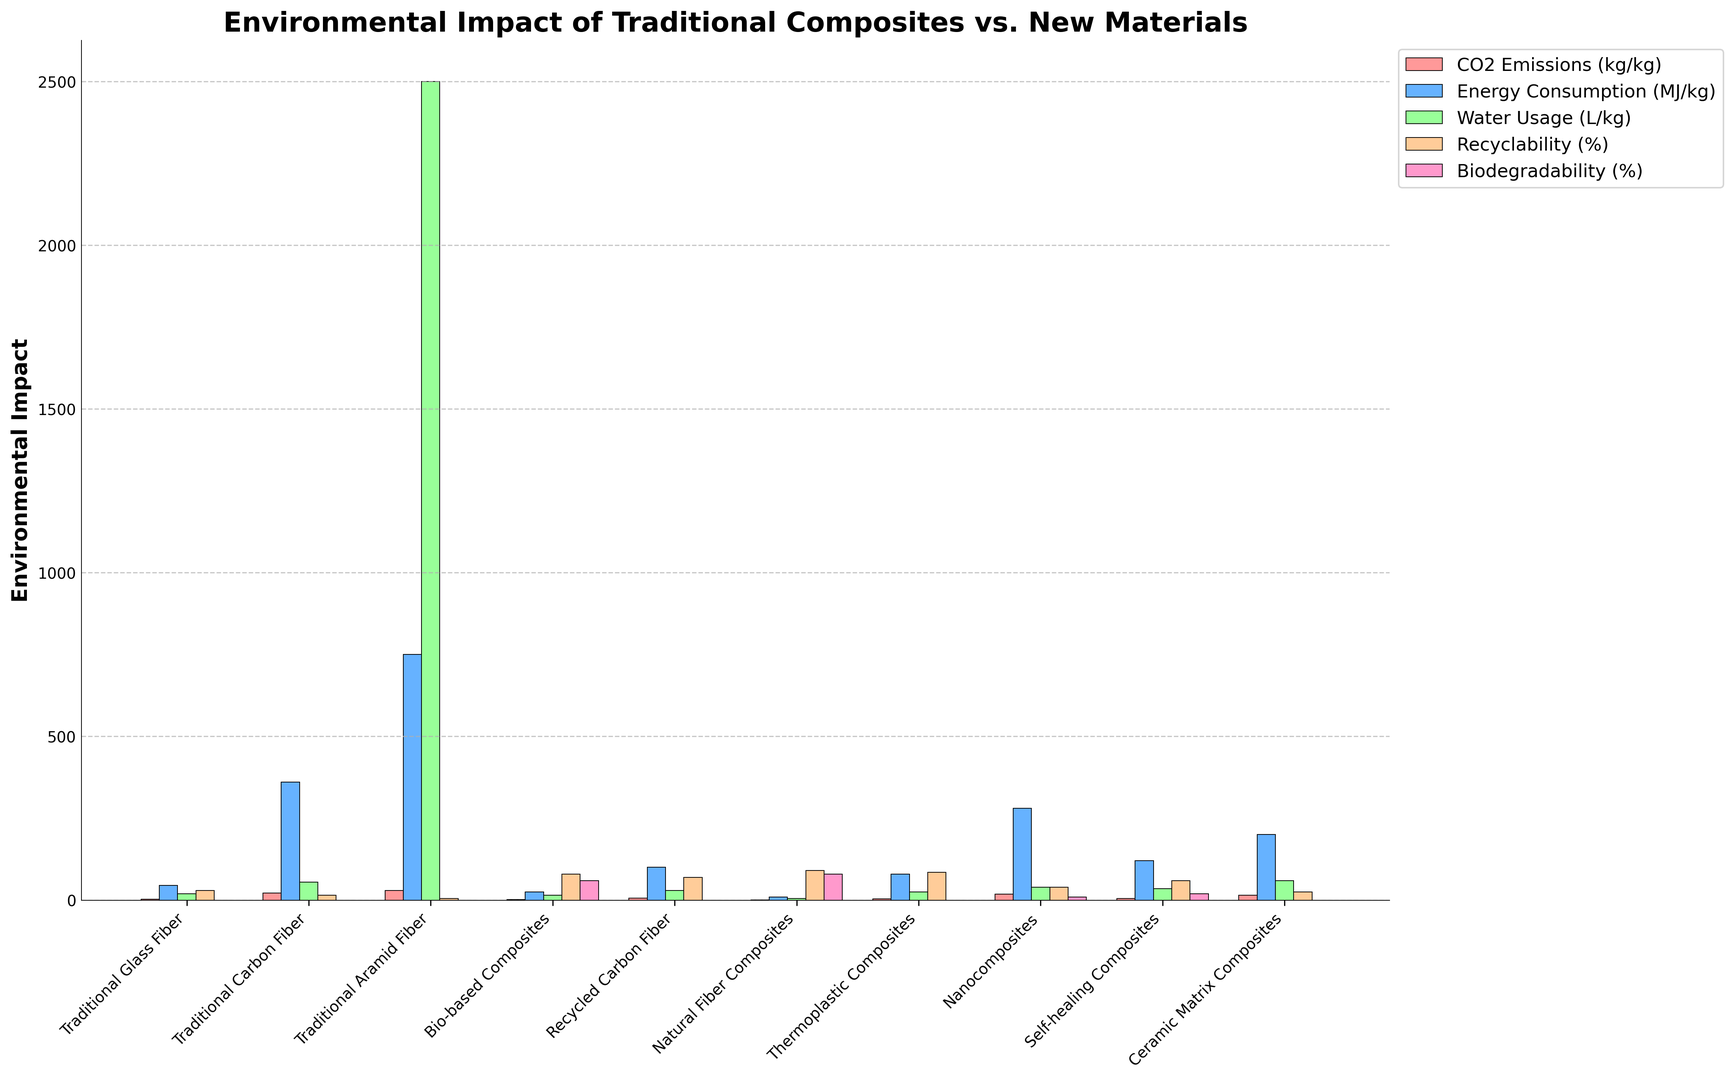What's the CO2 emission comparison between Traditional Carbon Fiber and Nanocomposites? Identify the bars representing Traditional Carbon Fiber and Nanocomposites for CO2 Emissions (colored in a distinct color). Compare the height of both bars. The CO2 emission for Traditional Carbon Fiber is 22 kg/kg and for Nanocomposites is 18 kg/kg.
Answer: Traditional Carbon Fiber has higher CO2 emissions Which material has the highest water usage? Locate the tallest bar representing each material type under the water usage category (colored in a specific shade). The Traditional Aramid Fiber bar is significantly taller, representing the highest water usage at 2500 L/kg
Answer: Traditional Aramid Fiber What is the combined recyclability percentage of Bio-based Composites and Natural Fiber Composites? Identify the bars for recyclability (colored in a particular color) and note their heights. Bio-based Composites have 80%, and Natural Fiber Composites have 90%. Sum these two values: 80% + 90% = 170%
Answer: 170% Which material has the lowest energy consumption, and what is the value? Locate the shortest bar in the energy consumption category (colored appropriately). Natural Fiber Composites has the shortest bar at 10 MJ/kg
Answer: Natural Fiber Composites, 10 MJ/kg What is the difference in recyclability between Thermoplastic Composites and Traditional Glass Fiber? Identify the bars for recyclability (differentiated color) for the two materials. Thermoplastic Composites have 85%, and Traditional Glass Fiber has 30%. Calculate the difference: 85% - 30% = 55%
Answer: 55% Which materials have biodegradability percentages greater than 50%? Identify the relevant bars for biodegradability (colored differently) and compare their heights. Both Bio-based Composites (60%) and Natural Fiber Composites (80%) have values above 50% %
Answer: Bio-based Composites, Natural Fiber Composites By how much does the energy consumption of Recycled Carbon Fiber exceed that of Traditional Glass Fiber? Locate the energy consumption bars for both materials (identified by color). Traditional Glass Fiber has 45 MJ/kg, and Recycled Carbon Fiber has 100 MJ/kg. Subtract these values: 100 MJ/kg - 45 MJ/kg = 55 MJ/kg
Answer: 55 MJ/kg Which material shows the highest biodegradability percentage among traditional composites? Find the bars corresponding to biodegradability for traditional composites, identified by their color. All traditional composites (Glass Fiber, Carbon Fiber, and Aramid Fiber) have 0% biodegradability.
Answer: None What is the average CO2 emission of Bio-based Composites and Natural Fiber Composites? Identify the CO2 emission bars for the two materials (in a specific color). Their values are summed up: 1.2 kg/kg (Bio-based) + 0.8 kg/kg (Natural Fiber), and then divided by 2 to find the average: (1.2 + 0.8) / 2 = 1 kg/kg
Answer: 1 kg/kg Which material has the highest percentage difference in biodegradability compared to Nanocomposites? Identify biodegradability bars (particular color) for all materials and compute the percentage difference compared to Nanocomposites (10%). Bio-based Composites have a biodegradability percentage of 60%, and Natural Fiber Composites have 80%. The latter has the highest percentage difference: 80% - 10% = 70%.
Answer: Natural Fiber Composites, 70% 